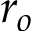<formula> <loc_0><loc_0><loc_500><loc_500>r _ { o }</formula> 